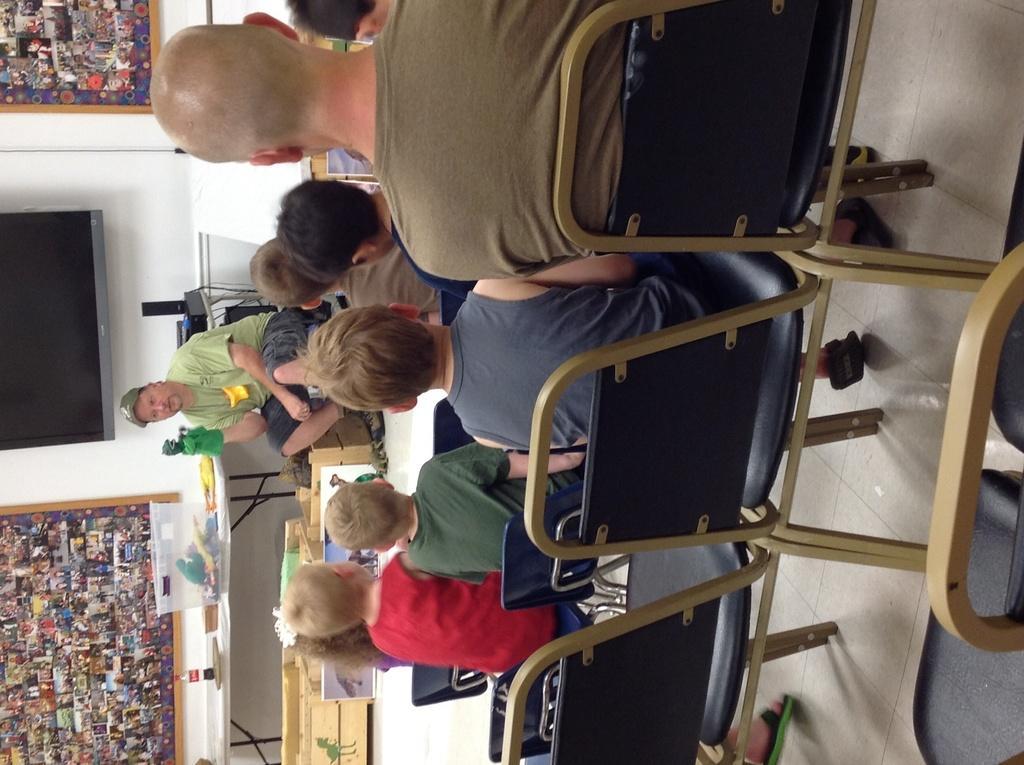How would you summarize this image in a sentence or two? There are few people sitting on the chair and listening to the person sitting over here and telling them something. In the background we can see screen,wall and few things on the table. 